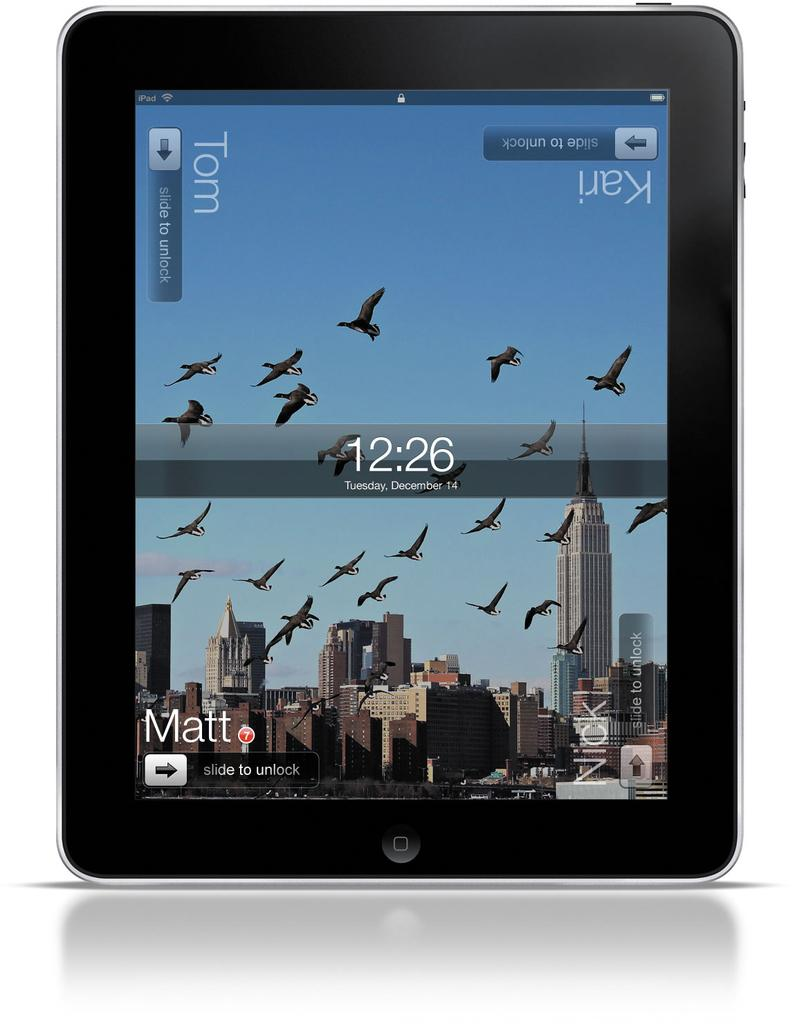What is the main object in the image? There is a tab in the image. What can be seen on the tab? The tab contains images of buildings and text. What is happening in the sky in the image? Birds are flying in the image. What else is visible in the image besides the tab? The sky is visible in the image. How many toes can be seen on the tab in the image? There are no toes present on the tab or in the image. What type of oil is being used by the birds in the image? There is no oil or indication of oil use in the image; the birds are simply flying. 